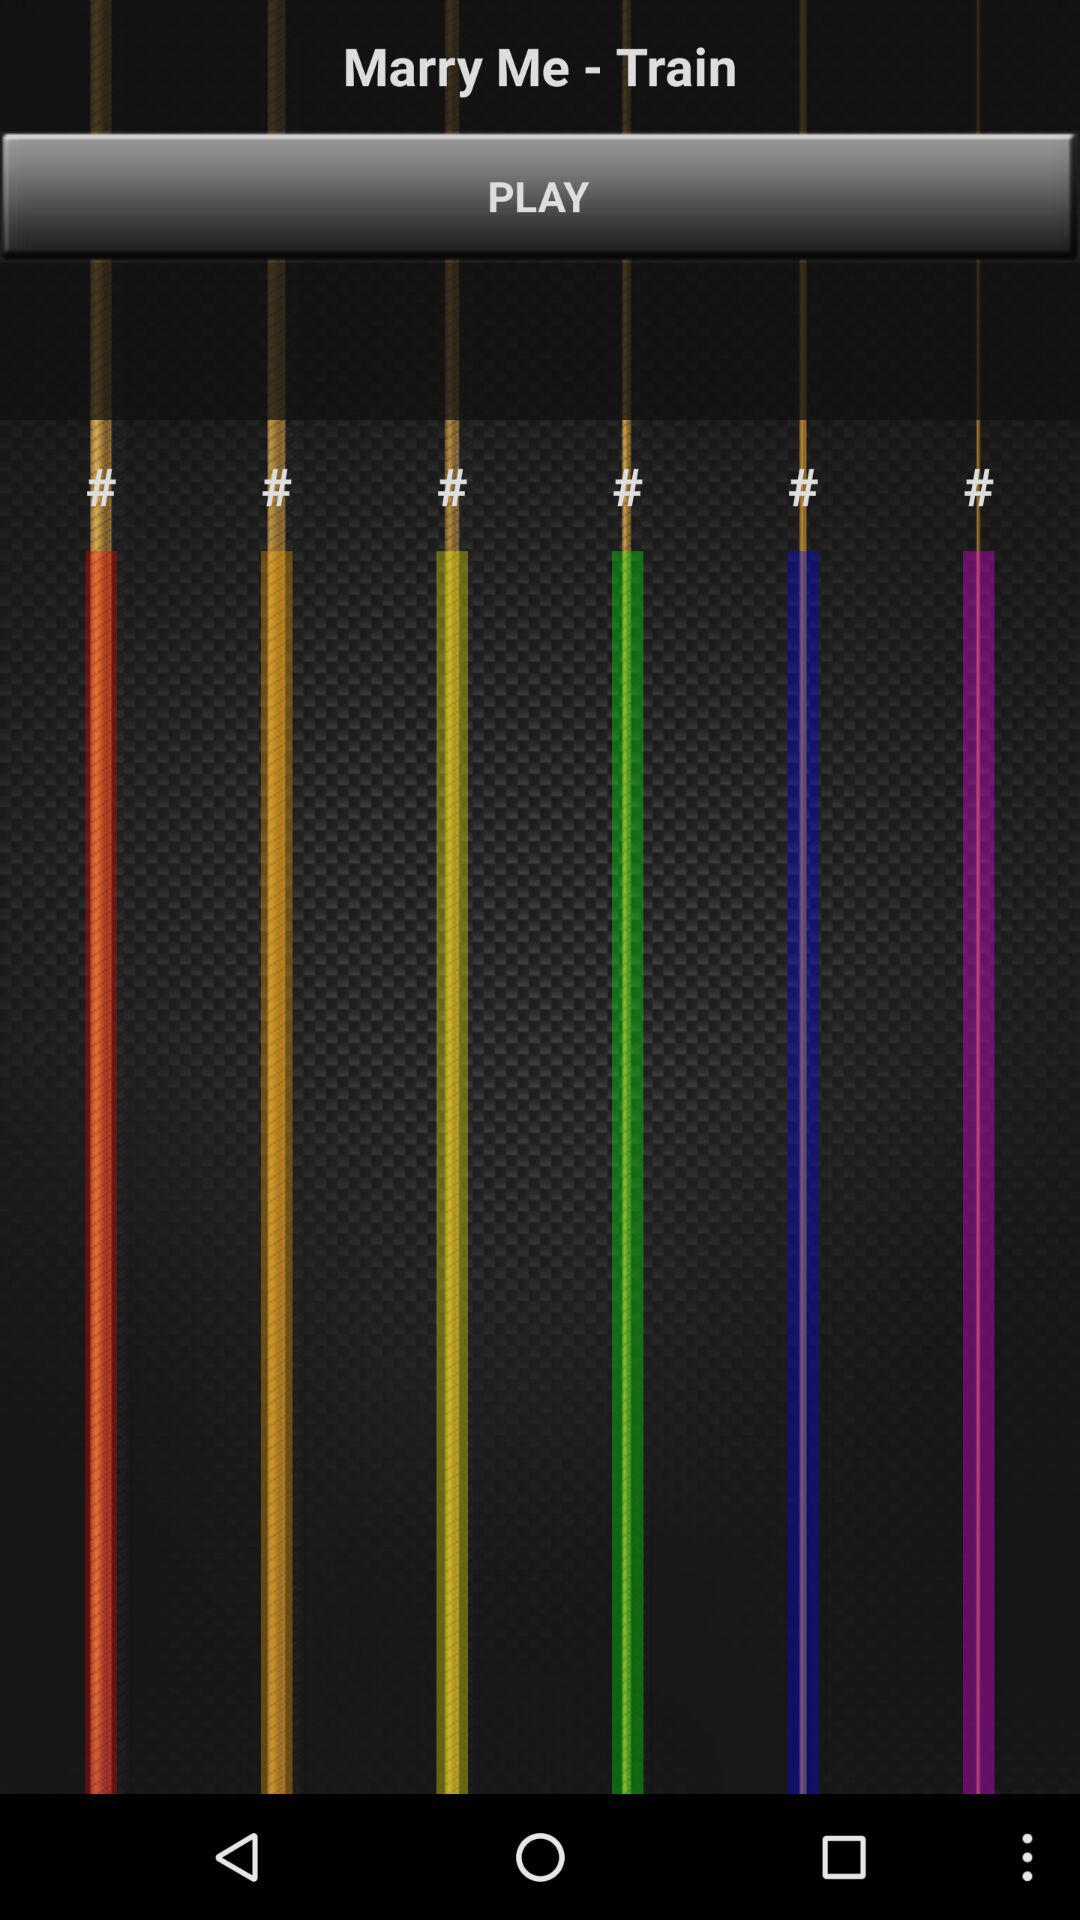Which song is chosen to be played? The chosen song is "Marry Me". 